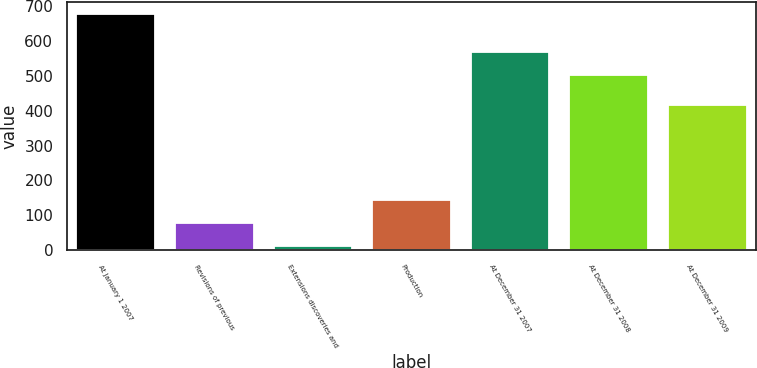Convert chart to OTSL. <chart><loc_0><loc_0><loc_500><loc_500><bar_chart><fcel>At January 1 2007<fcel>Revisions of previous<fcel>Extensions discoveries and<fcel>Production<fcel>At December 31 2007<fcel>At December 31 2008<fcel>At December 31 2009<nl><fcel>677<fcel>77.6<fcel>11<fcel>144.2<fcel>568.6<fcel>502<fcel>417<nl></chart> 